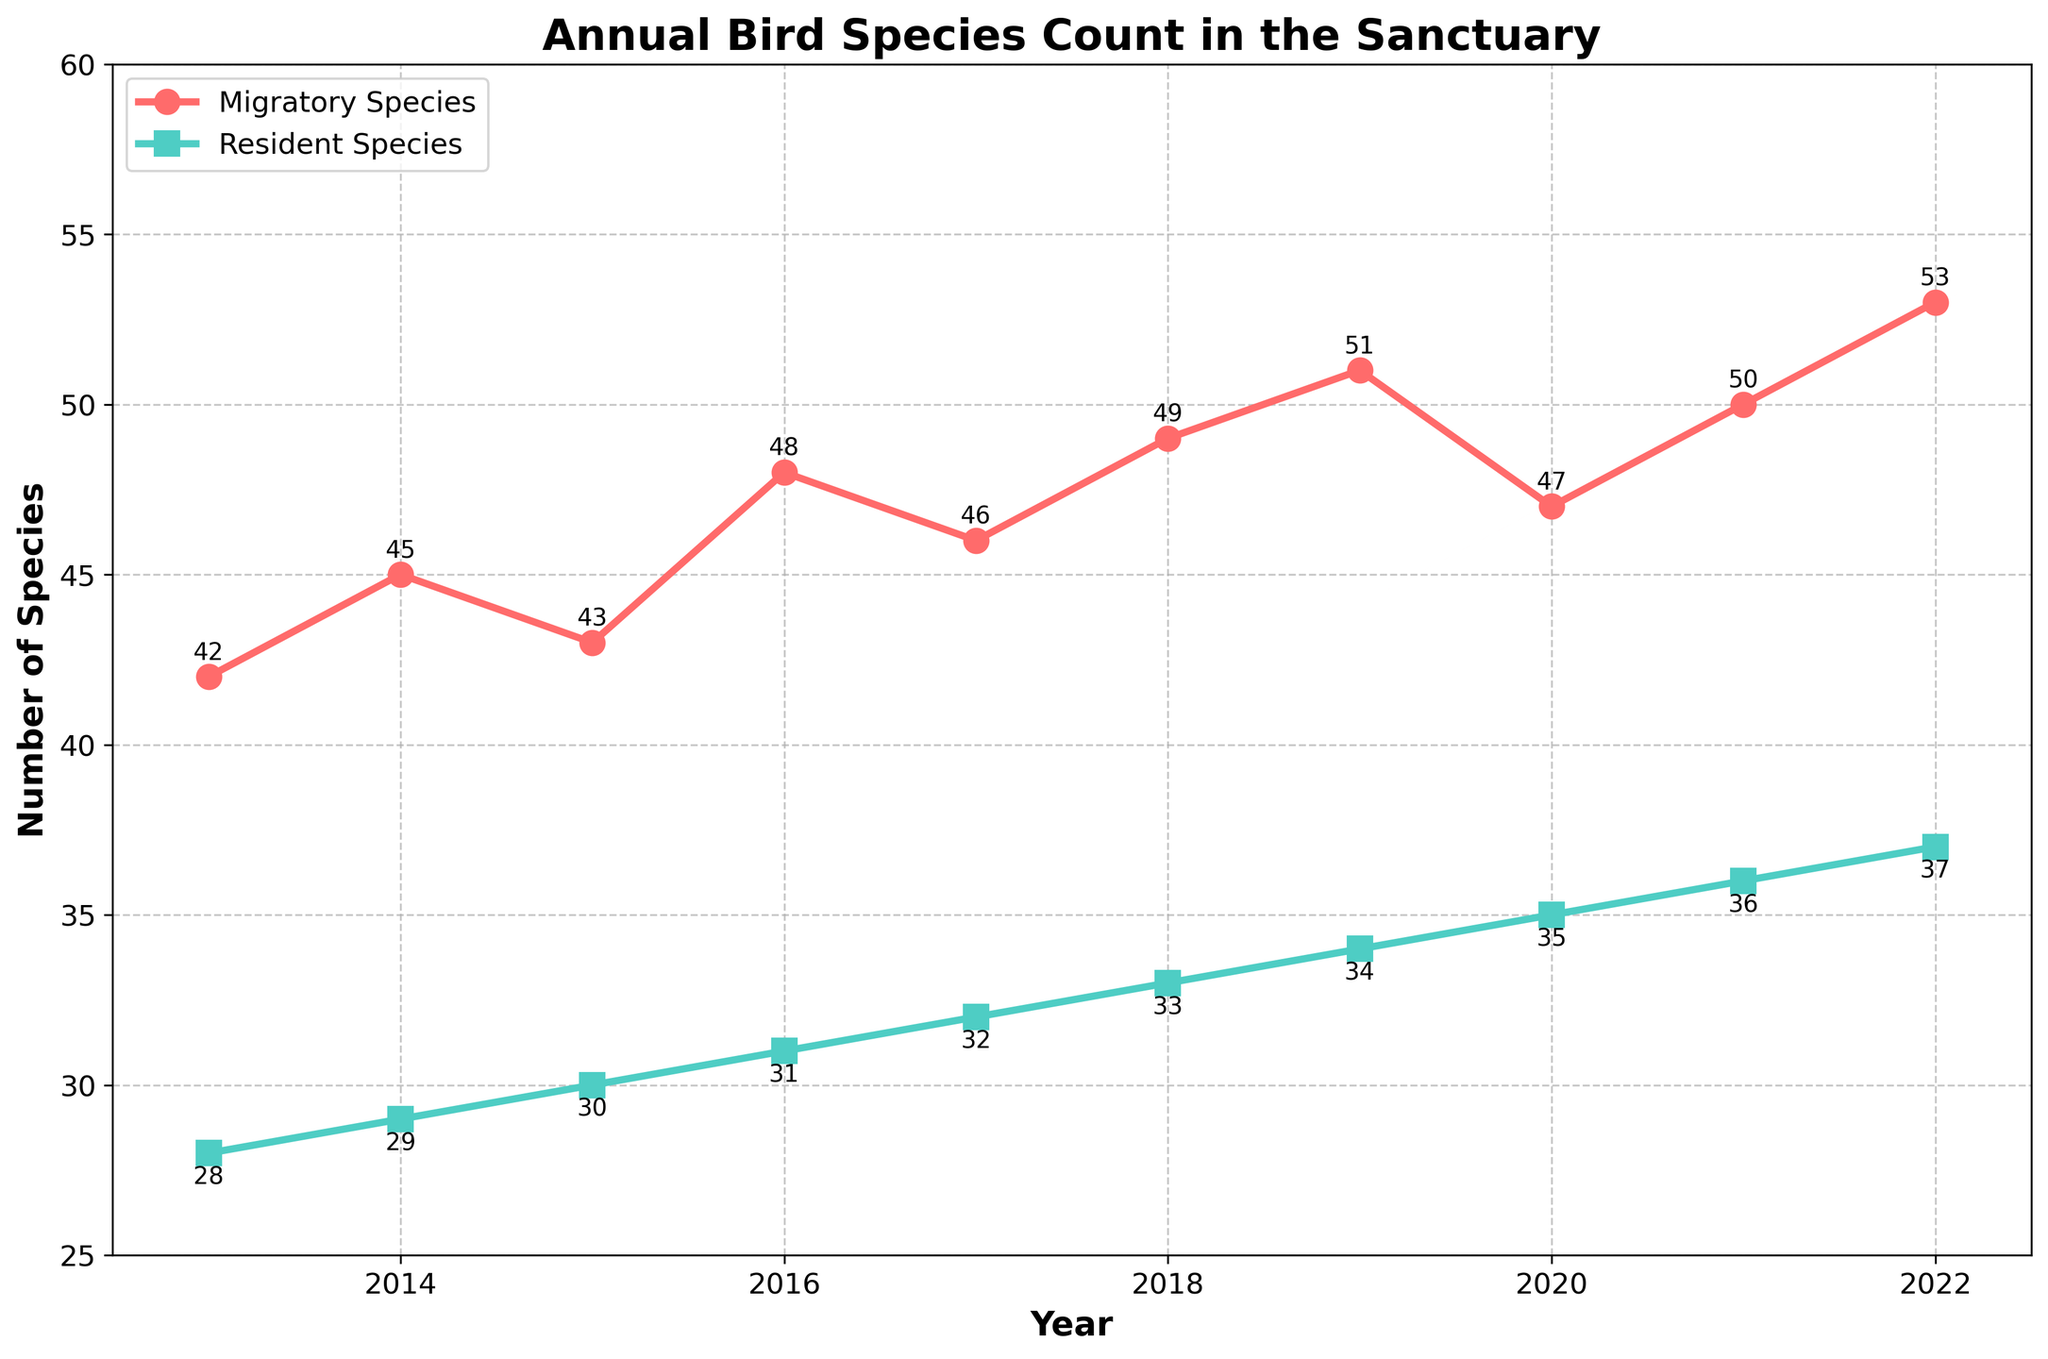How many migratory and resident species were recorded in 2022? Look at the data points for the year 2022 on the plot. The number of migratory species is marked with an 'o' and the number of resident species is marked with an 's'.
Answer: 53 migratory, 37 resident Which year saw the highest number of migratory species? By observing the plot, look for the highest point on the red line, which represents migratory species. The highest point is in the year 2022.
Answer: 2022 What is the difference in the number of resident species between 2013 and 2022? Look at the data points for the year 2013 and 2022. The number of resident species in 2013 is 28, and in 2022 it is 37. The difference is 37 - 28.
Answer: 9 What is the average count of migratory species over the decade? Sum the number of migratory species for each year: 42+45+43+48+46+49+51+47+50+53 = 474. Divide this sum by the number of years (10).
Answer: 47.4 In which year did the number of resident species surpass 30 for the first time? Observe the points on the green line representing resident species. The value surpasses 30 between 2015 (30) and 2016 (31).
Answer: 2016 Are there more migratory or resident species in 2020? Compare the data points for 2020. The red line (migratory species) is at 47, while the green line (resident species) is at 35.
Answer: More migratory species Which line is steeper, indicating a rapid increase, between the years 2017 and 2018? Compare the slope between two years for both lines. The green line (resident species) shows a consistent, gentler increase, whereas the red line (migratory species) shows a steeper rise from 46 to 49.
Answer: Red line (migratory species) What is the sum of migratory and resident species in the year 2021? Add the number of migratory species (50) and resident species (36) for the year 2021.
Answer: 86 During which years did both migratory and resident species show an upward trend every year? Examine the trend lines for both types of species. From 2013 to 2019, both lines generally show an upward trend
Answer: 2013 to 2019 By how much did the number of resident species increase between 2018 and 2019? Look at the data points for resident species in 2018 and 2019. The number in 2018 is 33, and in 2019 it is 34. The increase is 34 - 33.
Answer: 1 